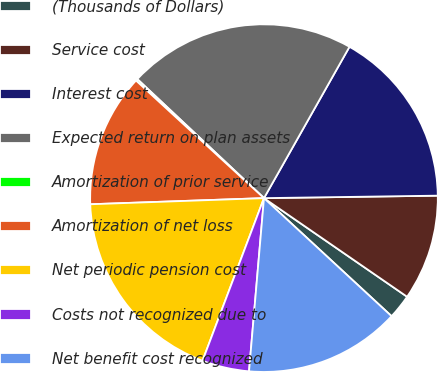<chart> <loc_0><loc_0><loc_500><loc_500><pie_chart><fcel>(Thousands of Dollars)<fcel>Service cost<fcel>Interest cost<fcel>Expected return on plan assets<fcel>Amortization of prior service<fcel>Amortization of net loss<fcel>Net periodic pension cost<fcel>Costs not recognized due to<fcel>Net benefit cost recognized<nl><fcel>2.28%<fcel>9.83%<fcel>16.59%<fcel>21.18%<fcel>0.18%<fcel>12.39%<fcel>18.69%<fcel>4.38%<fcel>14.49%<nl></chart> 